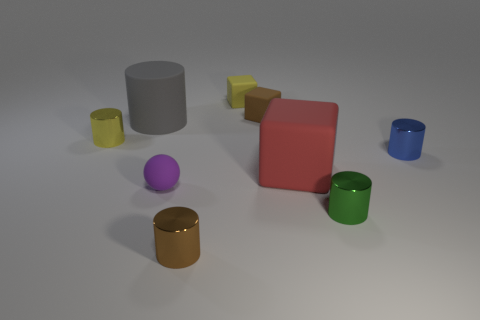Can you describe the arrangement of the objects with regard to their colors? Certainly! The objects appear strategically placed and consist of various colors, including yellow, purple, red, blue, green, gray, and brown. They seem to be arranged with no specific order in terms of the color spectrum, giving a casual yet visually pleasing display. 